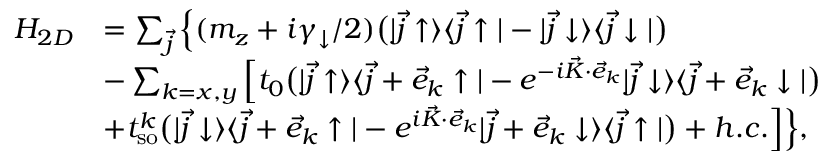<formula> <loc_0><loc_0><loc_500><loc_500>\begin{array} { r l } { H _ { 2 D } } & { = \sum _ { \vec { j } } \left \{ ( m _ { z } + i \gamma _ { \downarrow } / 2 ) \left ( | \vec { j } \uparrow \rangle \langle \vec { j } \uparrow | - | \vec { j } \downarrow \rangle \langle \vec { j } \downarrow | \right ) } \\ & { - \sum _ { k = x , y } \left [ t _ { 0 } \left ( | \vec { j } \uparrow \rangle \langle \vec { j } + \vec { e } _ { k } \uparrow | - e ^ { - i \vec { K } \cdot \vec { e } _ { k } } | \vec { j } \downarrow \rangle \langle \vec { j } + \vec { e } _ { k } \downarrow | \right ) } \\ & { + t _ { s o } ^ { k } \left ( | \vec { j } \downarrow \rangle \langle \vec { j } + \vec { e } _ { k } \uparrow | - e ^ { i \vec { K } \cdot \vec { e } _ { k } } | \vec { j } + \vec { e } _ { k } \downarrow \rangle \langle \vec { j } \uparrow | \right ) + h . c . \right ] \right \} , } \end{array}</formula> 